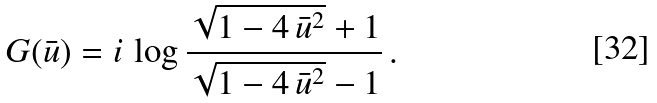Convert formula to latex. <formula><loc_0><loc_0><loc_500><loc_500>G ( \bar { u } ) = i \, \log \frac { \sqrt { 1 - 4 \, \bar { u } ^ { 2 } } + 1 } { \sqrt { 1 - 4 \, \bar { u } ^ { 2 } } - 1 } \, .</formula> 